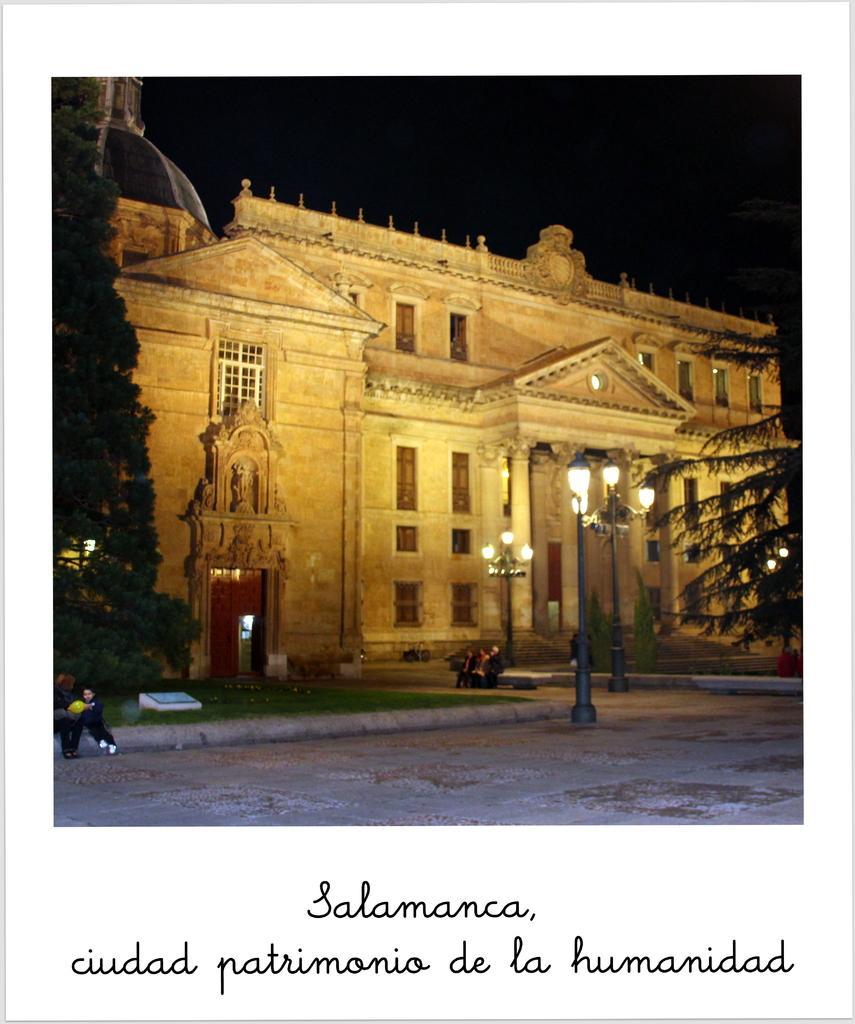Describe this image in one or two sentences. In the foreground of this image, on the bottom, there is some text. In the image, there is pavement, light poles, grass, few persons sitting, trees, building and the dark sky. 